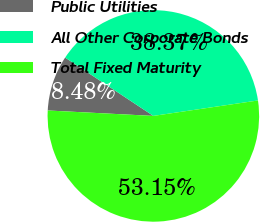Convert chart. <chart><loc_0><loc_0><loc_500><loc_500><pie_chart><fcel>Public Utilities<fcel>All Other Corporate Bonds<fcel>Total Fixed Maturity<nl><fcel>8.48%<fcel>38.37%<fcel>53.15%<nl></chart> 